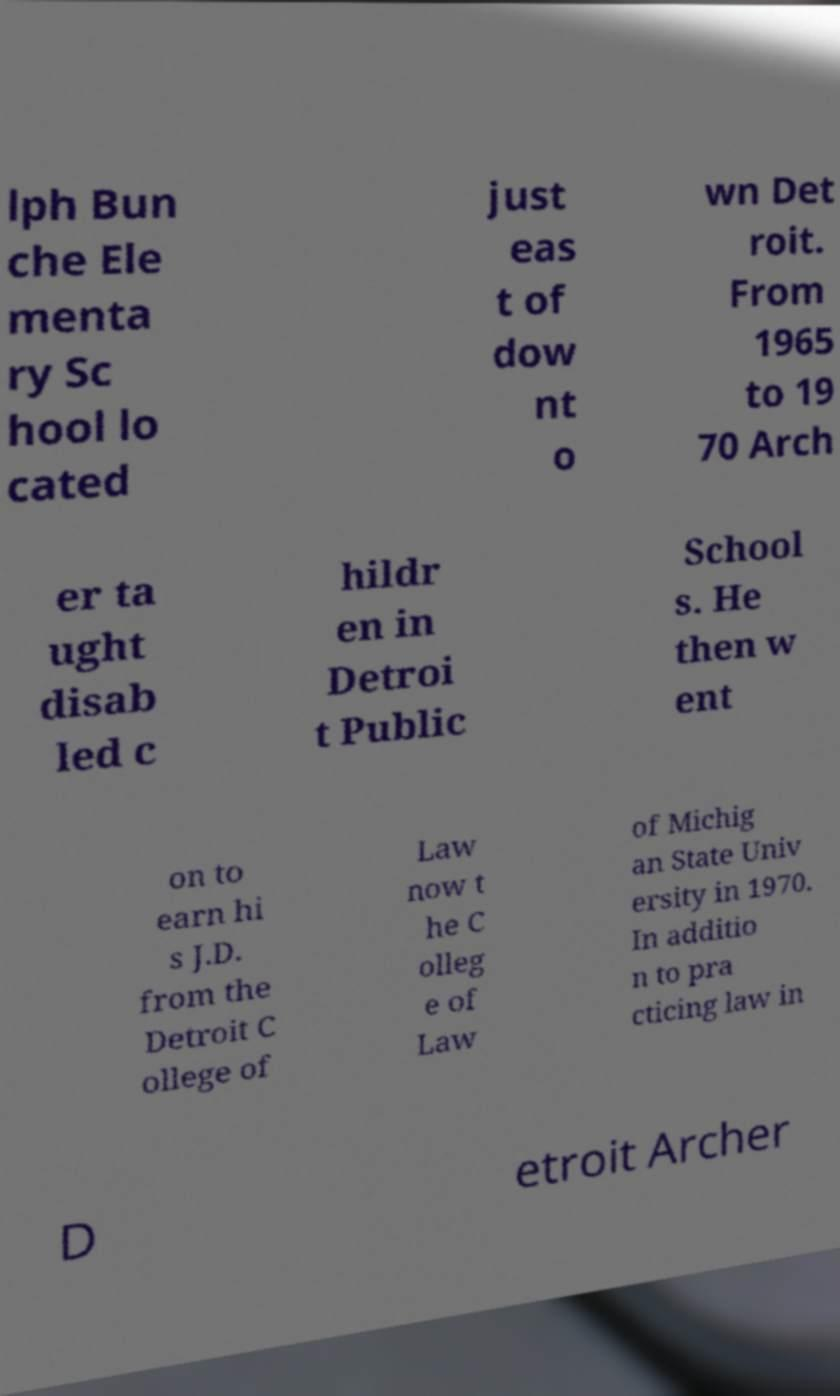There's text embedded in this image that I need extracted. Can you transcribe it verbatim? lph Bun che Ele menta ry Sc hool lo cated just eas t of dow nt o wn Det roit. From 1965 to 19 70 Arch er ta ught disab led c hildr en in Detroi t Public School s. He then w ent on to earn hi s J.D. from the Detroit C ollege of Law now t he C olleg e of Law of Michig an State Univ ersity in 1970. In additio n to pra cticing law in D etroit Archer 